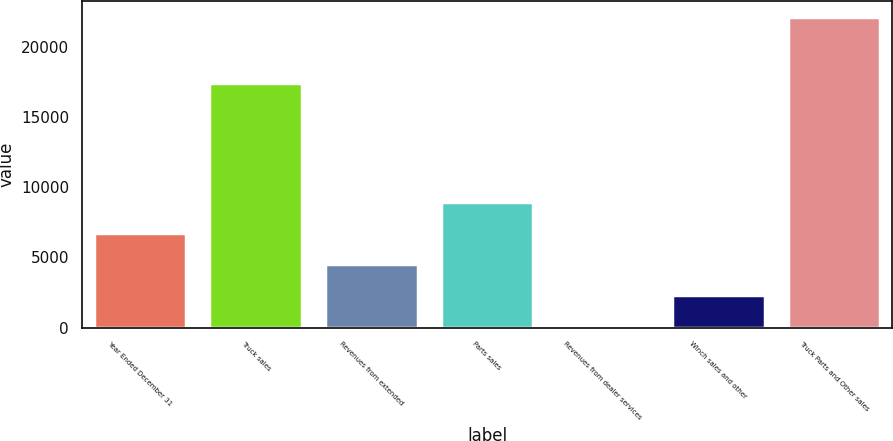<chart> <loc_0><loc_0><loc_500><loc_500><bar_chart><fcel>Year Ended December 31<fcel>Truck sales<fcel>Revenues from extended<fcel>Parts sales<fcel>Revenues from dealer services<fcel>Winch sales and other<fcel>Truck Parts and Other sales<nl><fcel>6716.48<fcel>17447.8<fcel>4513.32<fcel>8919.64<fcel>107<fcel>2310.16<fcel>22138.6<nl></chart> 